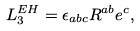Convert formula to latex. <formula><loc_0><loc_0><loc_500><loc_500>L _ { 3 } ^ { E H } = \epsilon _ { a b c } R ^ { a b } e ^ { c } ,</formula> 